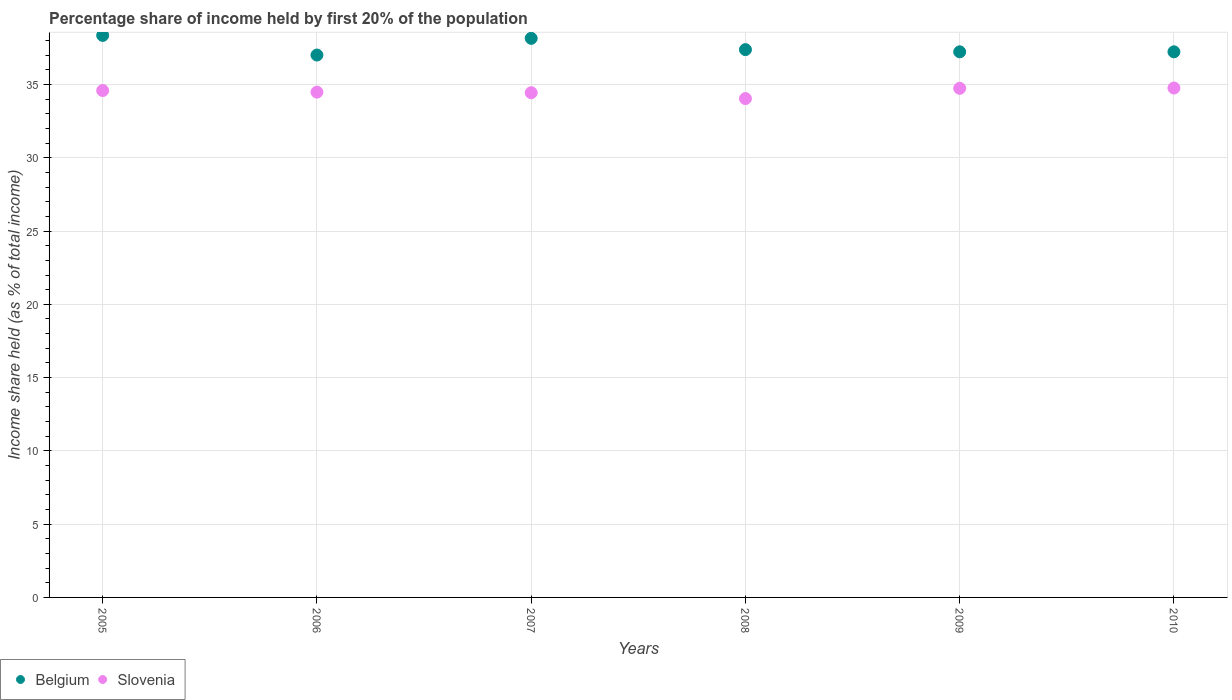How many different coloured dotlines are there?
Provide a succinct answer. 2. What is the share of income held by first 20% of the population in Slovenia in 2005?
Your answer should be compact. 34.59. Across all years, what is the maximum share of income held by first 20% of the population in Slovenia?
Give a very brief answer. 34.76. Across all years, what is the minimum share of income held by first 20% of the population in Belgium?
Offer a terse response. 37.01. In which year was the share of income held by first 20% of the population in Belgium minimum?
Offer a terse response. 2006. What is the total share of income held by first 20% of the population in Belgium in the graph?
Your response must be concise. 225.35. What is the difference between the share of income held by first 20% of the population in Slovenia in 2005 and that in 2006?
Your answer should be very brief. 0.11. What is the difference between the share of income held by first 20% of the population in Belgium in 2006 and the share of income held by first 20% of the population in Slovenia in 2005?
Make the answer very short. 2.42. What is the average share of income held by first 20% of the population in Belgium per year?
Provide a succinct answer. 37.56. In the year 2009, what is the difference between the share of income held by first 20% of the population in Slovenia and share of income held by first 20% of the population in Belgium?
Ensure brevity in your answer.  -2.49. In how many years, is the share of income held by first 20% of the population in Slovenia greater than 5 %?
Your answer should be very brief. 6. What is the ratio of the share of income held by first 20% of the population in Belgium in 2006 to that in 2009?
Your response must be concise. 0.99. What is the difference between the highest and the second highest share of income held by first 20% of the population in Slovenia?
Your answer should be very brief. 0.02. What is the difference between the highest and the lowest share of income held by first 20% of the population in Slovenia?
Offer a very short reply. 0.72. Is the sum of the share of income held by first 20% of the population in Belgium in 2007 and 2009 greater than the maximum share of income held by first 20% of the population in Slovenia across all years?
Your answer should be compact. Yes. How many dotlines are there?
Your answer should be compact. 2. How many years are there in the graph?
Keep it short and to the point. 6. What is the title of the graph?
Offer a very short reply. Percentage share of income held by first 20% of the population. Does "Upper middle income" appear as one of the legend labels in the graph?
Give a very brief answer. No. What is the label or title of the X-axis?
Your answer should be compact. Years. What is the label or title of the Y-axis?
Offer a terse response. Income share held (as % of total income). What is the Income share held (as % of total income) of Belgium in 2005?
Keep it short and to the point. 38.35. What is the Income share held (as % of total income) of Slovenia in 2005?
Your answer should be very brief. 34.59. What is the Income share held (as % of total income) in Belgium in 2006?
Offer a very short reply. 37.01. What is the Income share held (as % of total income) in Slovenia in 2006?
Your answer should be very brief. 34.48. What is the Income share held (as % of total income) in Belgium in 2007?
Provide a succinct answer. 38.15. What is the Income share held (as % of total income) of Slovenia in 2007?
Your answer should be very brief. 34.44. What is the Income share held (as % of total income) in Belgium in 2008?
Make the answer very short. 37.38. What is the Income share held (as % of total income) in Slovenia in 2008?
Offer a very short reply. 34.04. What is the Income share held (as % of total income) in Belgium in 2009?
Ensure brevity in your answer.  37.23. What is the Income share held (as % of total income) in Slovenia in 2009?
Ensure brevity in your answer.  34.74. What is the Income share held (as % of total income) in Belgium in 2010?
Your answer should be compact. 37.23. What is the Income share held (as % of total income) in Slovenia in 2010?
Offer a very short reply. 34.76. Across all years, what is the maximum Income share held (as % of total income) of Belgium?
Your answer should be very brief. 38.35. Across all years, what is the maximum Income share held (as % of total income) in Slovenia?
Your answer should be very brief. 34.76. Across all years, what is the minimum Income share held (as % of total income) of Belgium?
Ensure brevity in your answer.  37.01. Across all years, what is the minimum Income share held (as % of total income) in Slovenia?
Ensure brevity in your answer.  34.04. What is the total Income share held (as % of total income) in Belgium in the graph?
Ensure brevity in your answer.  225.35. What is the total Income share held (as % of total income) of Slovenia in the graph?
Provide a succinct answer. 207.05. What is the difference between the Income share held (as % of total income) in Belgium in 2005 and that in 2006?
Ensure brevity in your answer.  1.34. What is the difference between the Income share held (as % of total income) of Slovenia in 2005 and that in 2006?
Offer a very short reply. 0.11. What is the difference between the Income share held (as % of total income) in Belgium in 2005 and that in 2008?
Provide a succinct answer. 0.97. What is the difference between the Income share held (as % of total income) of Slovenia in 2005 and that in 2008?
Provide a succinct answer. 0.55. What is the difference between the Income share held (as % of total income) in Belgium in 2005 and that in 2009?
Provide a succinct answer. 1.12. What is the difference between the Income share held (as % of total income) of Belgium in 2005 and that in 2010?
Provide a succinct answer. 1.12. What is the difference between the Income share held (as % of total income) of Slovenia in 2005 and that in 2010?
Your answer should be compact. -0.17. What is the difference between the Income share held (as % of total income) of Belgium in 2006 and that in 2007?
Ensure brevity in your answer.  -1.14. What is the difference between the Income share held (as % of total income) of Slovenia in 2006 and that in 2007?
Give a very brief answer. 0.04. What is the difference between the Income share held (as % of total income) of Belgium in 2006 and that in 2008?
Ensure brevity in your answer.  -0.37. What is the difference between the Income share held (as % of total income) of Slovenia in 2006 and that in 2008?
Keep it short and to the point. 0.44. What is the difference between the Income share held (as % of total income) of Belgium in 2006 and that in 2009?
Ensure brevity in your answer.  -0.22. What is the difference between the Income share held (as % of total income) in Slovenia in 2006 and that in 2009?
Your response must be concise. -0.26. What is the difference between the Income share held (as % of total income) of Belgium in 2006 and that in 2010?
Provide a succinct answer. -0.22. What is the difference between the Income share held (as % of total income) of Slovenia in 2006 and that in 2010?
Provide a succinct answer. -0.28. What is the difference between the Income share held (as % of total income) of Belgium in 2007 and that in 2008?
Your answer should be very brief. 0.77. What is the difference between the Income share held (as % of total income) of Slovenia in 2007 and that in 2008?
Give a very brief answer. 0.4. What is the difference between the Income share held (as % of total income) of Slovenia in 2007 and that in 2009?
Offer a terse response. -0.3. What is the difference between the Income share held (as % of total income) of Belgium in 2007 and that in 2010?
Give a very brief answer. 0.92. What is the difference between the Income share held (as % of total income) of Slovenia in 2007 and that in 2010?
Give a very brief answer. -0.32. What is the difference between the Income share held (as % of total income) in Slovenia in 2008 and that in 2009?
Give a very brief answer. -0.7. What is the difference between the Income share held (as % of total income) of Slovenia in 2008 and that in 2010?
Your response must be concise. -0.72. What is the difference between the Income share held (as % of total income) in Slovenia in 2009 and that in 2010?
Keep it short and to the point. -0.02. What is the difference between the Income share held (as % of total income) of Belgium in 2005 and the Income share held (as % of total income) of Slovenia in 2006?
Provide a short and direct response. 3.87. What is the difference between the Income share held (as % of total income) in Belgium in 2005 and the Income share held (as % of total income) in Slovenia in 2007?
Keep it short and to the point. 3.91. What is the difference between the Income share held (as % of total income) in Belgium in 2005 and the Income share held (as % of total income) in Slovenia in 2008?
Your answer should be compact. 4.31. What is the difference between the Income share held (as % of total income) in Belgium in 2005 and the Income share held (as % of total income) in Slovenia in 2009?
Provide a succinct answer. 3.61. What is the difference between the Income share held (as % of total income) in Belgium in 2005 and the Income share held (as % of total income) in Slovenia in 2010?
Ensure brevity in your answer.  3.59. What is the difference between the Income share held (as % of total income) of Belgium in 2006 and the Income share held (as % of total income) of Slovenia in 2007?
Your response must be concise. 2.57. What is the difference between the Income share held (as % of total income) of Belgium in 2006 and the Income share held (as % of total income) of Slovenia in 2008?
Make the answer very short. 2.97. What is the difference between the Income share held (as % of total income) of Belgium in 2006 and the Income share held (as % of total income) of Slovenia in 2009?
Your answer should be very brief. 2.27. What is the difference between the Income share held (as % of total income) of Belgium in 2006 and the Income share held (as % of total income) of Slovenia in 2010?
Offer a terse response. 2.25. What is the difference between the Income share held (as % of total income) of Belgium in 2007 and the Income share held (as % of total income) of Slovenia in 2008?
Your answer should be compact. 4.11. What is the difference between the Income share held (as % of total income) of Belgium in 2007 and the Income share held (as % of total income) of Slovenia in 2009?
Give a very brief answer. 3.41. What is the difference between the Income share held (as % of total income) of Belgium in 2007 and the Income share held (as % of total income) of Slovenia in 2010?
Provide a short and direct response. 3.39. What is the difference between the Income share held (as % of total income) of Belgium in 2008 and the Income share held (as % of total income) of Slovenia in 2009?
Offer a very short reply. 2.64. What is the difference between the Income share held (as % of total income) in Belgium in 2008 and the Income share held (as % of total income) in Slovenia in 2010?
Provide a short and direct response. 2.62. What is the difference between the Income share held (as % of total income) of Belgium in 2009 and the Income share held (as % of total income) of Slovenia in 2010?
Provide a succinct answer. 2.47. What is the average Income share held (as % of total income) in Belgium per year?
Offer a very short reply. 37.56. What is the average Income share held (as % of total income) in Slovenia per year?
Make the answer very short. 34.51. In the year 2005, what is the difference between the Income share held (as % of total income) of Belgium and Income share held (as % of total income) of Slovenia?
Give a very brief answer. 3.76. In the year 2006, what is the difference between the Income share held (as % of total income) in Belgium and Income share held (as % of total income) in Slovenia?
Make the answer very short. 2.53. In the year 2007, what is the difference between the Income share held (as % of total income) of Belgium and Income share held (as % of total income) of Slovenia?
Give a very brief answer. 3.71. In the year 2008, what is the difference between the Income share held (as % of total income) in Belgium and Income share held (as % of total income) in Slovenia?
Offer a terse response. 3.34. In the year 2009, what is the difference between the Income share held (as % of total income) in Belgium and Income share held (as % of total income) in Slovenia?
Offer a terse response. 2.49. In the year 2010, what is the difference between the Income share held (as % of total income) in Belgium and Income share held (as % of total income) in Slovenia?
Provide a short and direct response. 2.47. What is the ratio of the Income share held (as % of total income) of Belgium in 2005 to that in 2006?
Provide a succinct answer. 1.04. What is the ratio of the Income share held (as % of total income) of Slovenia in 2005 to that in 2006?
Keep it short and to the point. 1. What is the ratio of the Income share held (as % of total income) in Belgium in 2005 to that in 2007?
Give a very brief answer. 1.01. What is the ratio of the Income share held (as % of total income) of Belgium in 2005 to that in 2008?
Keep it short and to the point. 1.03. What is the ratio of the Income share held (as % of total income) of Slovenia in 2005 to that in 2008?
Provide a succinct answer. 1.02. What is the ratio of the Income share held (as % of total income) of Belgium in 2005 to that in 2009?
Provide a succinct answer. 1.03. What is the ratio of the Income share held (as % of total income) of Belgium in 2005 to that in 2010?
Your answer should be compact. 1.03. What is the ratio of the Income share held (as % of total income) in Slovenia in 2005 to that in 2010?
Your response must be concise. 1. What is the ratio of the Income share held (as % of total income) in Belgium in 2006 to that in 2007?
Ensure brevity in your answer.  0.97. What is the ratio of the Income share held (as % of total income) of Belgium in 2006 to that in 2008?
Provide a short and direct response. 0.99. What is the ratio of the Income share held (as % of total income) of Slovenia in 2006 to that in 2008?
Give a very brief answer. 1.01. What is the ratio of the Income share held (as % of total income) of Slovenia in 2006 to that in 2010?
Give a very brief answer. 0.99. What is the ratio of the Income share held (as % of total income) in Belgium in 2007 to that in 2008?
Keep it short and to the point. 1.02. What is the ratio of the Income share held (as % of total income) of Slovenia in 2007 to that in 2008?
Provide a succinct answer. 1.01. What is the ratio of the Income share held (as % of total income) of Belgium in 2007 to that in 2009?
Make the answer very short. 1.02. What is the ratio of the Income share held (as % of total income) in Slovenia in 2007 to that in 2009?
Provide a short and direct response. 0.99. What is the ratio of the Income share held (as % of total income) of Belgium in 2007 to that in 2010?
Give a very brief answer. 1.02. What is the ratio of the Income share held (as % of total income) in Slovenia in 2007 to that in 2010?
Your answer should be very brief. 0.99. What is the ratio of the Income share held (as % of total income) of Belgium in 2008 to that in 2009?
Provide a short and direct response. 1. What is the ratio of the Income share held (as % of total income) of Slovenia in 2008 to that in 2009?
Provide a short and direct response. 0.98. What is the ratio of the Income share held (as % of total income) in Belgium in 2008 to that in 2010?
Give a very brief answer. 1. What is the ratio of the Income share held (as % of total income) of Slovenia in 2008 to that in 2010?
Keep it short and to the point. 0.98. What is the difference between the highest and the second highest Income share held (as % of total income) of Belgium?
Your response must be concise. 0.2. What is the difference between the highest and the second highest Income share held (as % of total income) of Slovenia?
Offer a very short reply. 0.02. What is the difference between the highest and the lowest Income share held (as % of total income) in Belgium?
Offer a terse response. 1.34. What is the difference between the highest and the lowest Income share held (as % of total income) in Slovenia?
Your answer should be very brief. 0.72. 